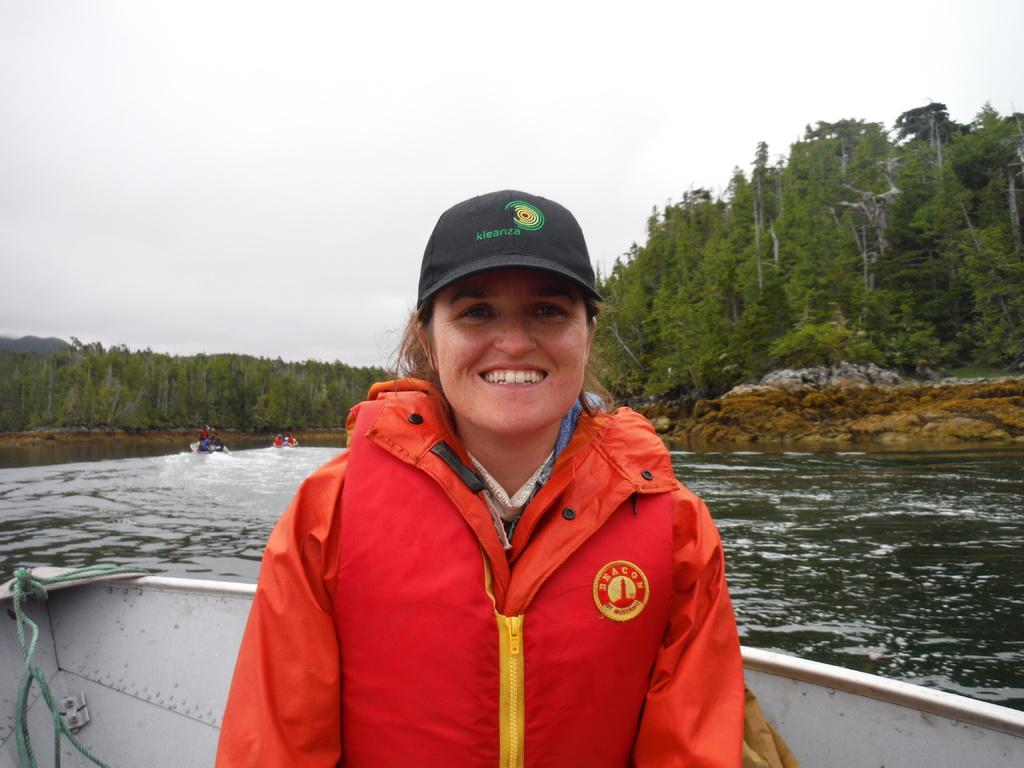What is the woman in the image doing? The woman is seated in a boat in the image. Are there any other boats in the image? Yes, there are other boats in the water in the image. What can be seen in the background of the image? Trees are visible in the image, and the sky appears cloudy. What is the woman wearing on her head? The woman is wearing a cap on her head. What type of cheese is the woman holding in the image? There is no cheese present in the image; the woman is wearing a cap on her head. 